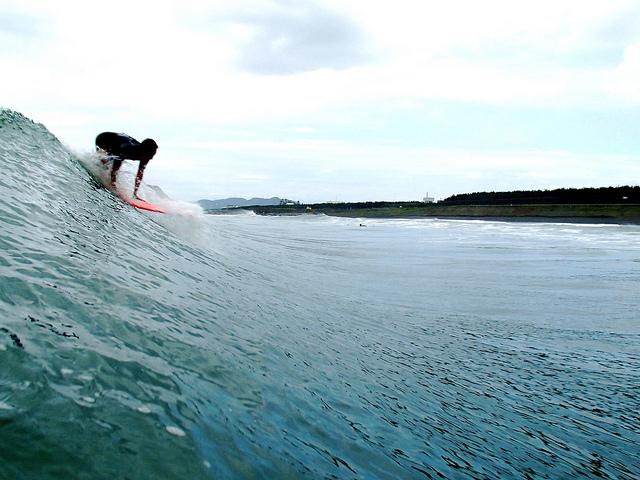What color is the surfboard?
Short answer required. Red. Is the surfer standing?
Answer briefly. No. Is that a huge wave?
Concise answer only. Yes. 